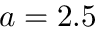Convert formula to latex. <formula><loc_0><loc_0><loc_500><loc_500>a = 2 . 5</formula> 